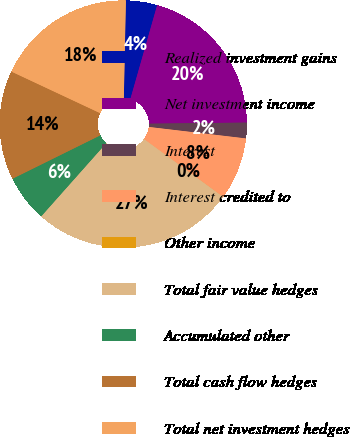<chart> <loc_0><loc_0><loc_500><loc_500><pie_chart><fcel>Realized investment gains<fcel>Net investment income<fcel>Interest<fcel>Interest credited to<fcel>Other income<fcel>Total fair value hedges<fcel>Accumulated other<fcel>Total cash flow hedges<fcel>Total net investment hedges<nl><fcel>4.09%<fcel>20.4%<fcel>2.05%<fcel>8.17%<fcel>0.01%<fcel>26.51%<fcel>6.13%<fcel>14.28%<fcel>18.36%<nl></chart> 